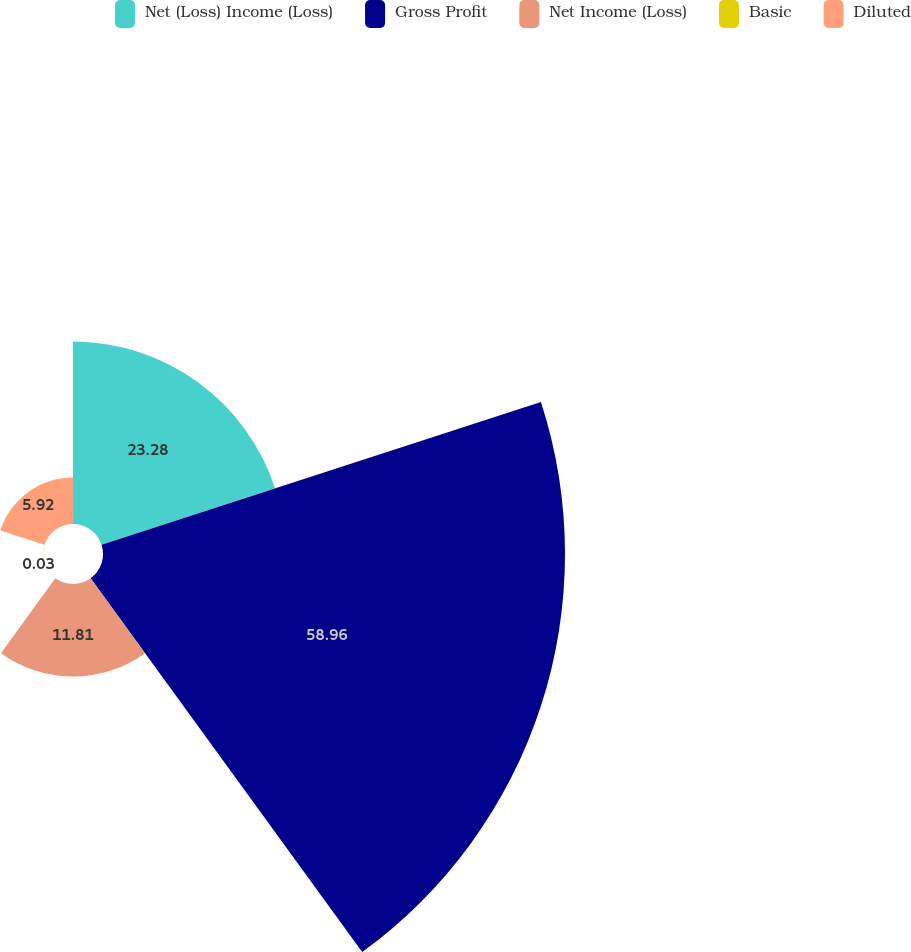Convert chart to OTSL. <chart><loc_0><loc_0><loc_500><loc_500><pie_chart><fcel>Net (Loss) Income (Loss)<fcel>Gross Profit<fcel>Net Income (Loss)<fcel>Basic<fcel>Diluted<nl><fcel>23.28%<fcel>58.95%<fcel>11.81%<fcel>0.03%<fcel>5.92%<nl></chart> 